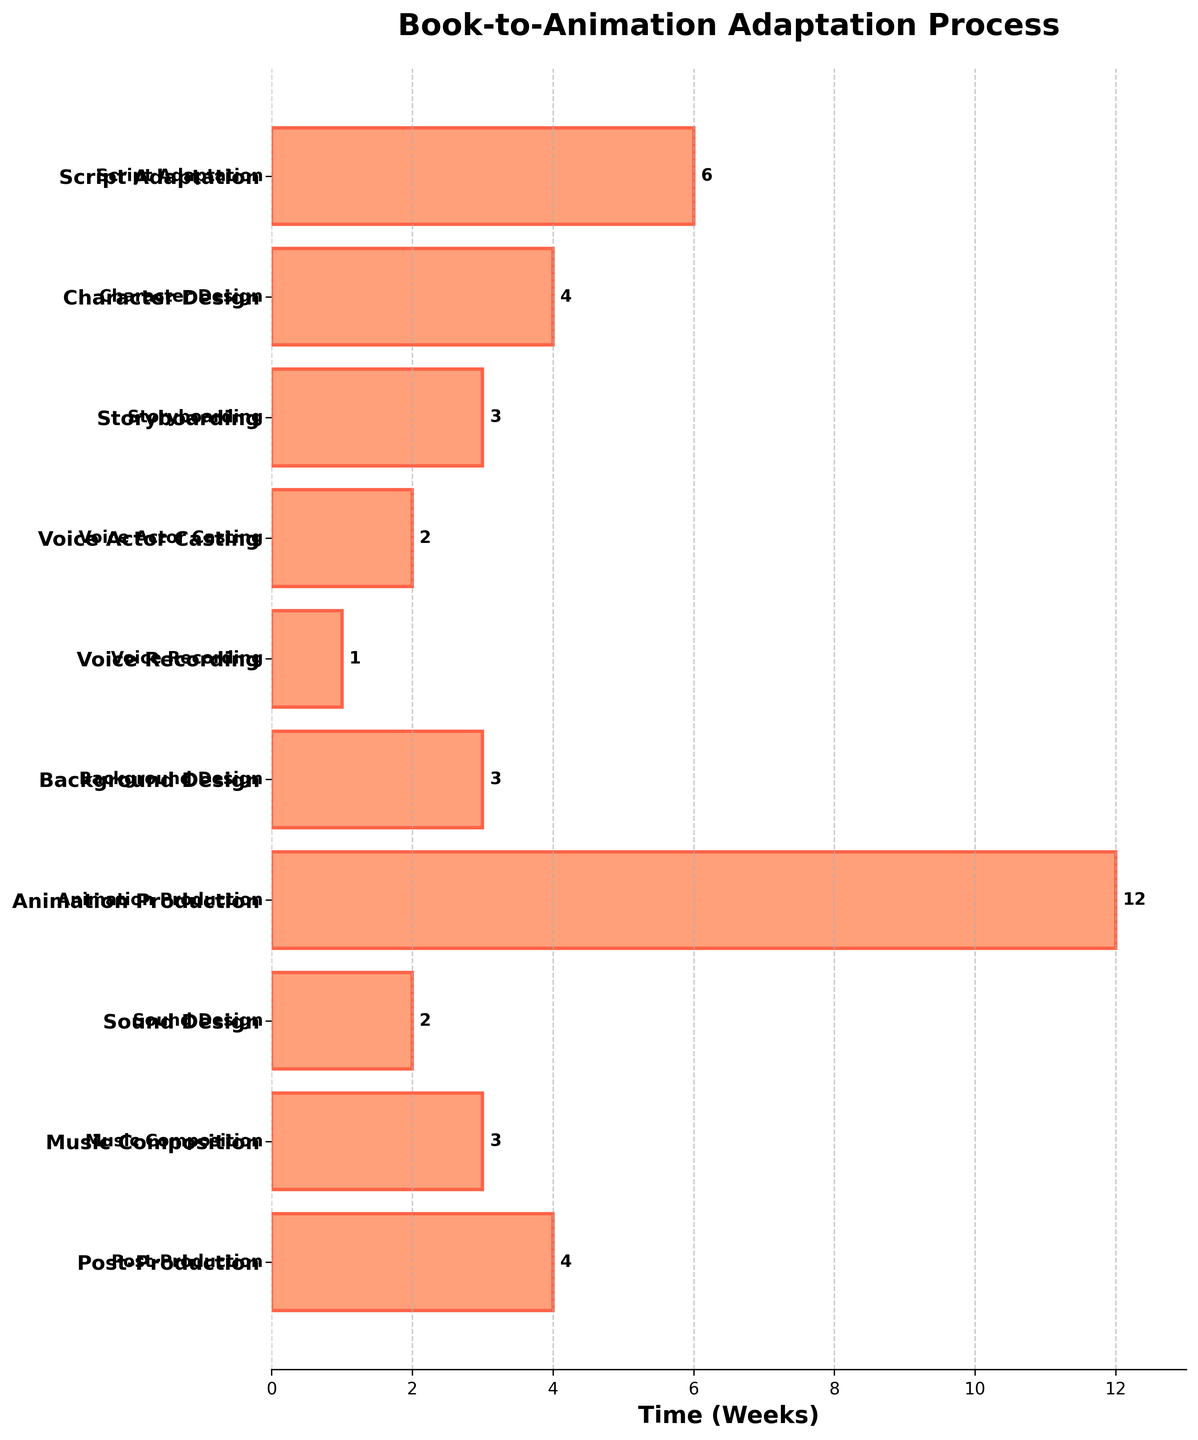what is the title of the figure? The title of the figure is given at the top and is clearly labeled as "Book-to-Animation Adaptation Process".
Answer: Book-to-Animation Adaptation Process What color is used for the bars? Observing the bars, they are filled with a light salmon color with an orange-red outline.
Answer: Light salmon with an orange-red outline What is the total time required for 'Script Adaptation' and 'Character Design' stages combined? The 'Script Adaptation' stage requires 6 weeks, and the 'Character Design' stage requires 4 weeks. Adding these two values results in a total of 10 weeks.
Answer: 10 weeks Which stage takes the longest time to complete? By comparing the lengths of all the bars, the 'Animation Production' stage is the longest, indicating it takes the most time.
Answer: Animation Production How many stages take exactly 3 weeks? Observing the lengths of the bars, the 'Storyboarding', 'Background Design', and 'Music Composition' stages each have bars that represent 3 weeks.
Answer: 3 stages What is the difference in time between the 'Voice Recording' and 'Sound Design' stages? The 'Voice Recording' stage takes 1 week, whereas the 'Sound Design' stage takes 2 weeks. Subtracting the times, the difference is 1 week.
Answer: 1 week Which stages take less than or equal to 2 weeks? The stages 'Voice Actor Casting' (2 weeks), 'Voice Recording' (1 week), and 'Sound Design' (2 weeks) all have times that are less than or equal to 2 weeks.
Answer: Voice Actor Casting, Voice Recording, Sound Design What is the average time taken for all stages combined? Adding all the times together: 6 + 4 + 3 + 2 + 1 + 3 + 12 + 2 + 3 + 4 = 40 weeks. There are 10 stages, so the average time is 40 / 10 = 4 weeks.
Answer: 4 weeks What is the difference between the stage that takes the maximum time and the stage that takes the minimum time? The maximum time taken is by 'Animation Production' (12 weeks) and the minimum time is by 'Voice Recording' (1 week). The difference is 12 - 1 = 11 weeks.
Answer: 11 weeks Which stage is positioned at the very top of the plot? The plot is inverted, so the 'Script Adaptation' stage, being the first entry, is positioned at the very top.
Answer: Script Adaptation 